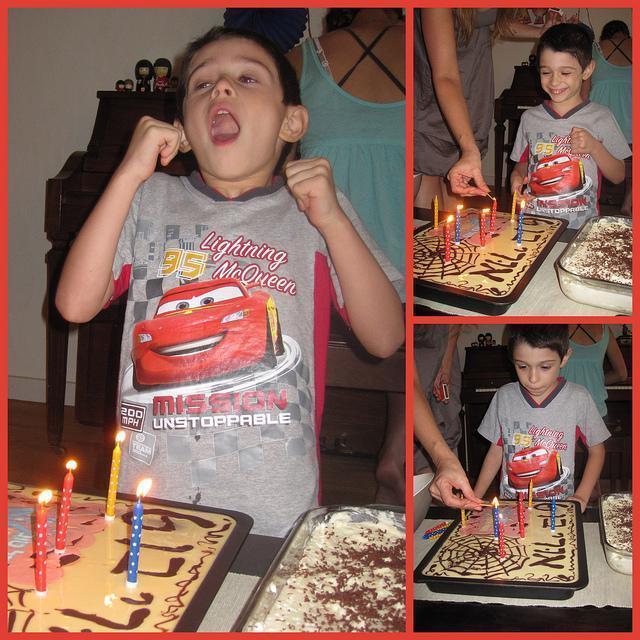How many dining tables are visible?
Give a very brief answer. 2. How many people can be seen?
Give a very brief answer. 8. How many cakes are visible?
Give a very brief answer. 5. How many horses are there?
Give a very brief answer. 0. 